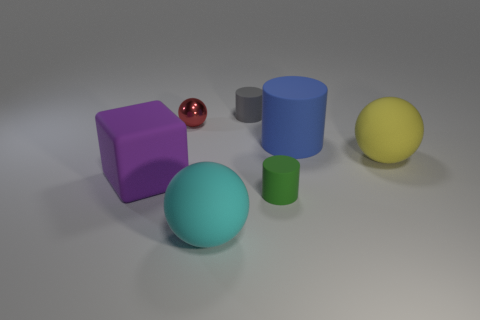Are there any other things that are made of the same material as the small red object?
Your answer should be very brief. No. Are there any other things that are the same shape as the gray object?
Make the answer very short. Yes. Is the shape of the rubber object that is behind the red object the same as the blue thing that is on the left side of the yellow matte ball?
Make the answer very short. Yes. There is a gray rubber cylinder; is it the same size as the sphere that is behind the yellow thing?
Give a very brief answer. Yes. Are there more big matte cubes than red cubes?
Provide a succinct answer. Yes. Is the big thing that is on the left side of the tiny metallic sphere made of the same material as the ball that is behind the big yellow ball?
Ensure brevity in your answer.  No. What material is the red object?
Keep it short and to the point. Metal. Is the number of large cylinders right of the red shiny ball greater than the number of small cyan balls?
Offer a very short reply. Yes. How many big purple things are on the right side of the rubber ball to the right of the small matte cylinder that is right of the gray thing?
Offer a very short reply. 0. What is the thing that is on the left side of the large yellow ball and on the right side of the green matte cylinder made of?
Offer a very short reply. Rubber. 